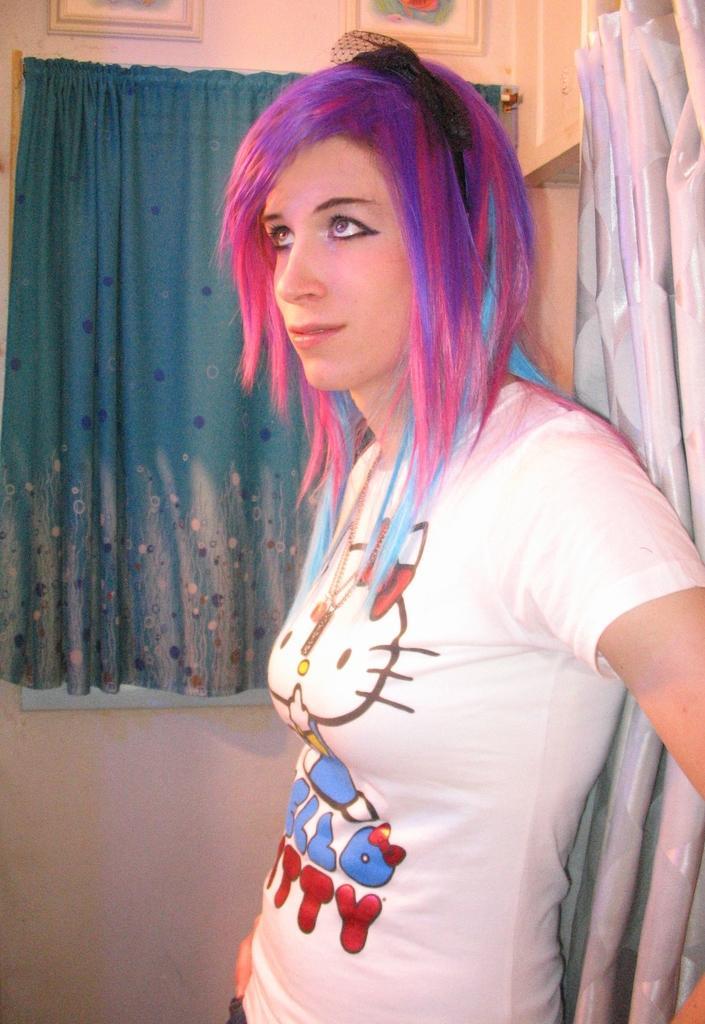Please provide a concise description of this image. In this image I see a woman and she is wearing white t-shirt and I see words written and I see the colorful hair. In the background I see the wall and I see 2 photo frames over here and I see the curtain over here and I can also see another curtain over here. 